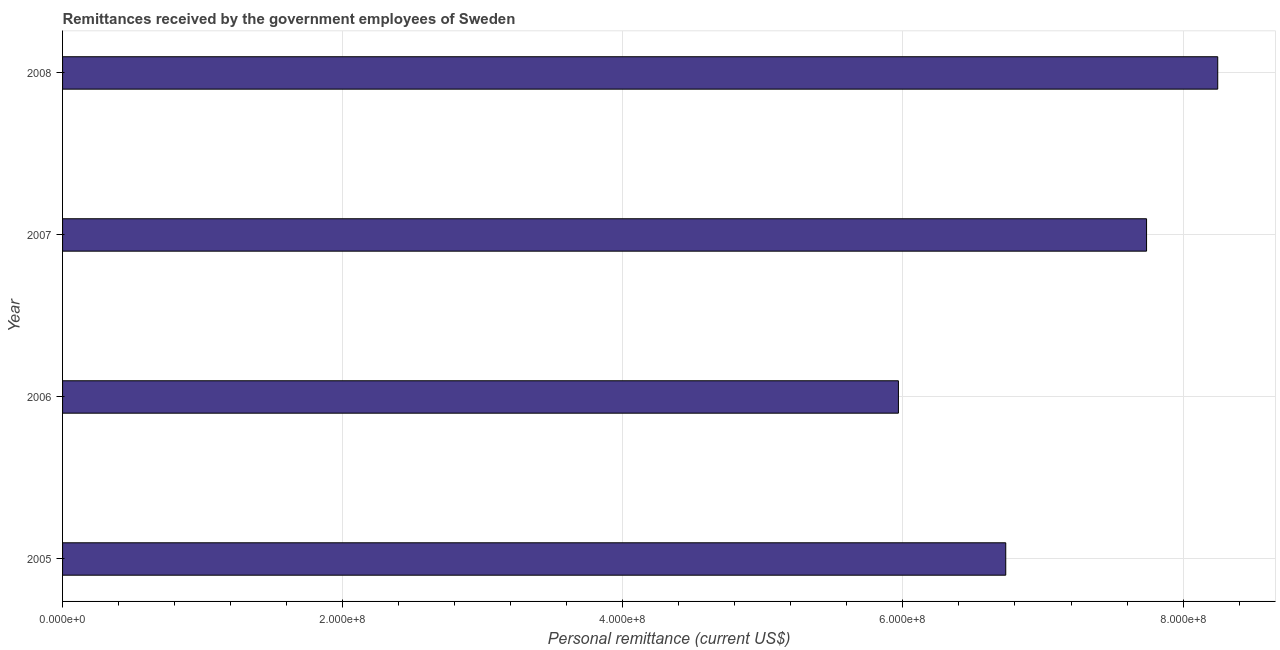Does the graph contain any zero values?
Give a very brief answer. No. Does the graph contain grids?
Keep it short and to the point. Yes. What is the title of the graph?
Ensure brevity in your answer.  Remittances received by the government employees of Sweden. What is the label or title of the X-axis?
Your response must be concise. Personal remittance (current US$). What is the personal remittances in 2005?
Make the answer very short. 6.73e+08. Across all years, what is the maximum personal remittances?
Ensure brevity in your answer.  8.25e+08. Across all years, what is the minimum personal remittances?
Offer a very short reply. 5.97e+08. In which year was the personal remittances maximum?
Your answer should be compact. 2008. What is the sum of the personal remittances?
Provide a short and direct response. 2.87e+09. What is the difference between the personal remittances in 2005 and 2008?
Make the answer very short. -1.51e+08. What is the average personal remittances per year?
Your answer should be compact. 7.17e+08. What is the median personal remittances?
Offer a terse response. 7.24e+08. What is the ratio of the personal remittances in 2006 to that in 2007?
Offer a terse response. 0.77. Is the personal remittances in 2006 less than that in 2007?
Keep it short and to the point. Yes. Is the difference between the personal remittances in 2007 and 2008 greater than the difference between any two years?
Give a very brief answer. No. What is the difference between the highest and the second highest personal remittances?
Provide a succinct answer. 5.08e+07. What is the difference between the highest and the lowest personal remittances?
Your answer should be compact. 2.28e+08. How many bars are there?
Offer a terse response. 4. What is the difference between two consecutive major ticks on the X-axis?
Provide a short and direct response. 2.00e+08. Are the values on the major ticks of X-axis written in scientific E-notation?
Your answer should be very brief. Yes. What is the Personal remittance (current US$) of 2005?
Give a very brief answer. 6.73e+08. What is the Personal remittance (current US$) of 2006?
Offer a very short reply. 5.97e+08. What is the Personal remittance (current US$) of 2007?
Your response must be concise. 7.74e+08. What is the Personal remittance (current US$) of 2008?
Keep it short and to the point. 8.25e+08. What is the difference between the Personal remittance (current US$) in 2005 and 2006?
Your response must be concise. 7.66e+07. What is the difference between the Personal remittance (current US$) in 2005 and 2007?
Your response must be concise. -1.01e+08. What is the difference between the Personal remittance (current US$) in 2005 and 2008?
Your answer should be very brief. -1.51e+08. What is the difference between the Personal remittance (current US$) in 2006 and 2007?
Keep it short and to the point. -1.77e+08. What is the difference between the Personal remittance (current US$) in 2006 and 2008?
Your answer should be very brief. -2.28e+08. What is the difference between the Personal remittance (current US$) in 2007 and 2008?
Make the answer very short. -5.08e+07. What is the ratio of the Personal remittance (current US$) in 2005 to that in 2006?
Provide a short and direct response. 1.13. What is the ratio of the Personal remittance (current US$) in 2005 to that in 2007?
Keep it short and to the point. 0.87. What is the ratio of the Personal remittance (current US$) in 2005 to that in 2008?
Your answer should be compact. 0.82. What is the ratio of the Personal remittance (current US$) in 2006 to that in 2007?
Ensure brevity in your answer.  0.77. What is the ratio of the Personal remittance (current US$) in 2006 to that in 2008?
Keep it short and to the point. 0.72. What is the ratio of the Personal remittance (current US$) in 2007 to that in 2008?
Provide a short and direct response. 0.94. 